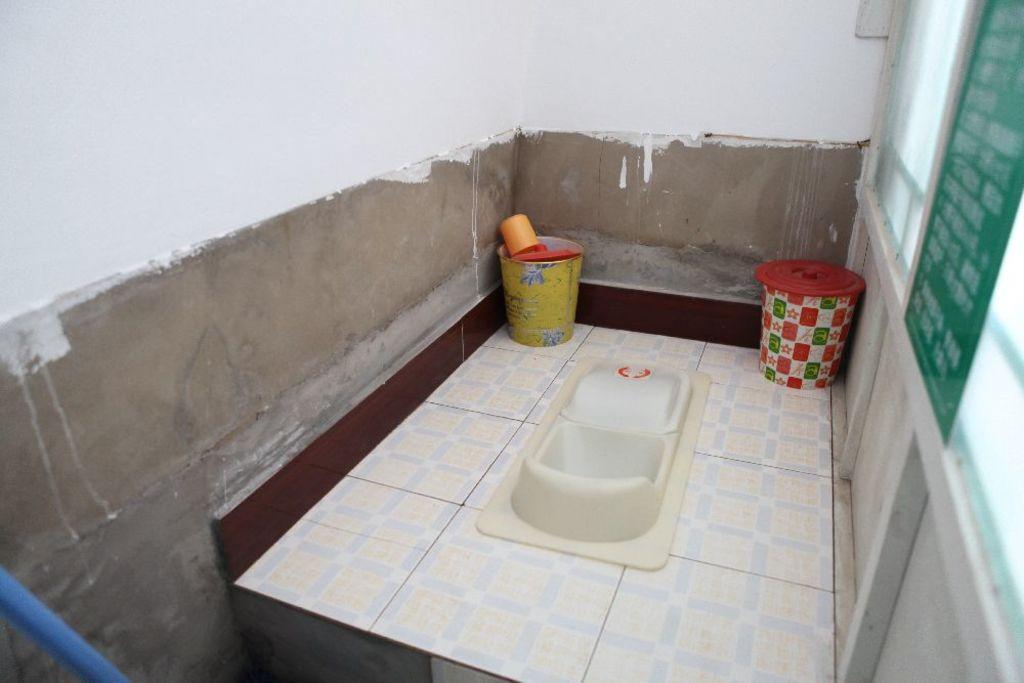Can you describe this image briefly? In this image, we can see an inside view of a bathroom. There is a commode and bins in the middle of the image. 